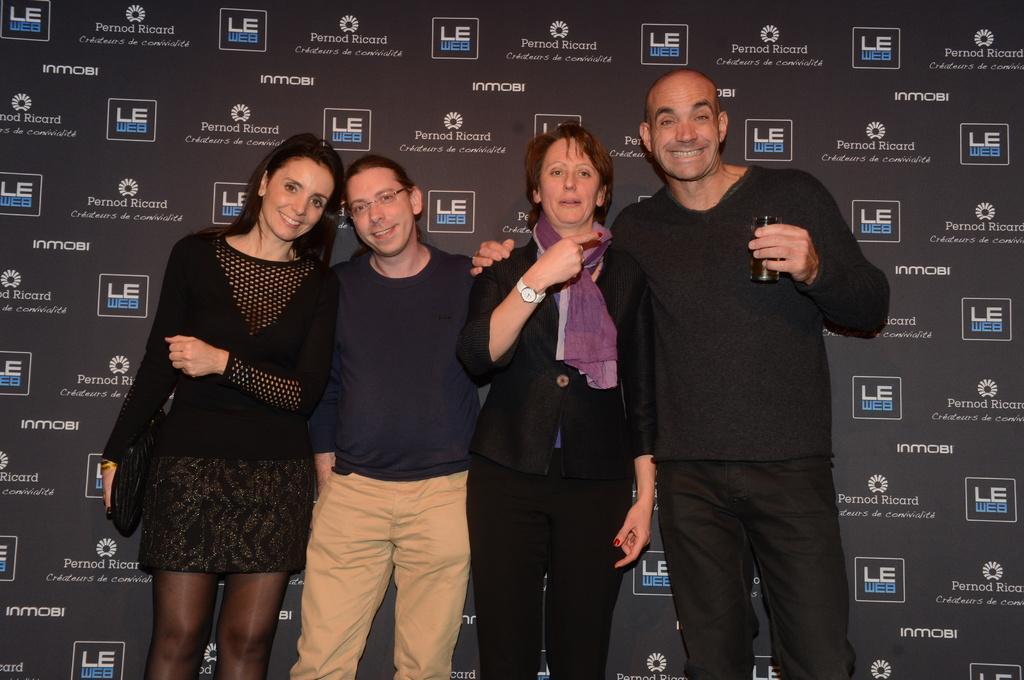Please provide a concise description of this image. These four people are standing. These three people are smiling. This man is holding a glass. This woman a scarf. Background we can see hoarding. 